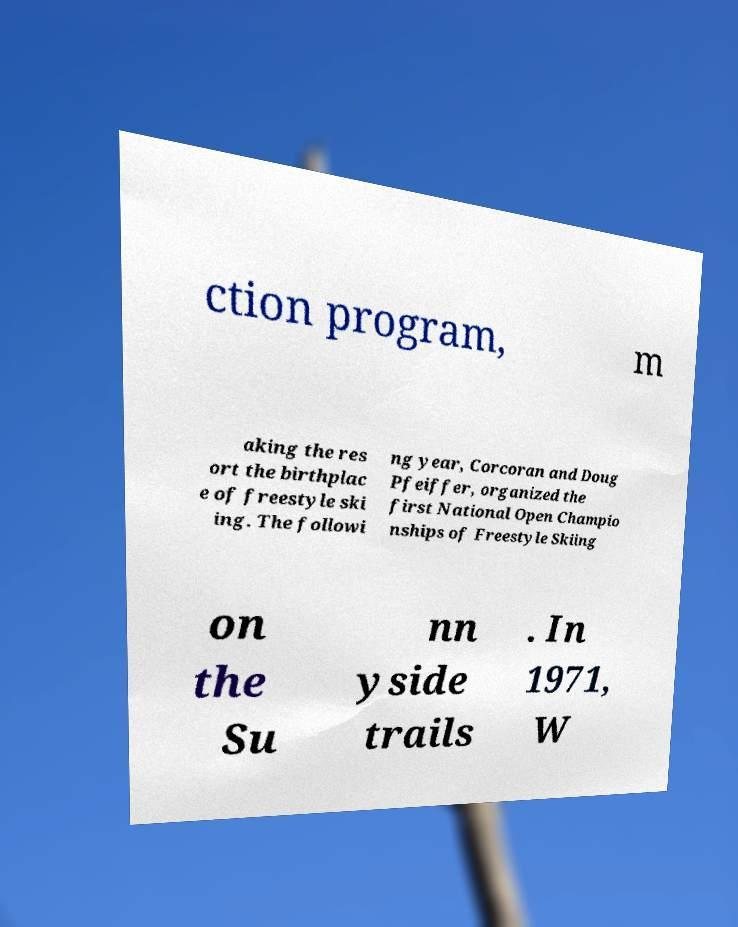There's text embedded in this image that I need extracted. Can you transcribe it verbatim? ction program, m aking the res ort the birthplac e of freestyle ski ing. The followi ng year, Corcoran and Doug Pfeiffer, organized the first National Open Champio nships of Freestyle Skiing on the Su nn yside trails . In 1971, W 